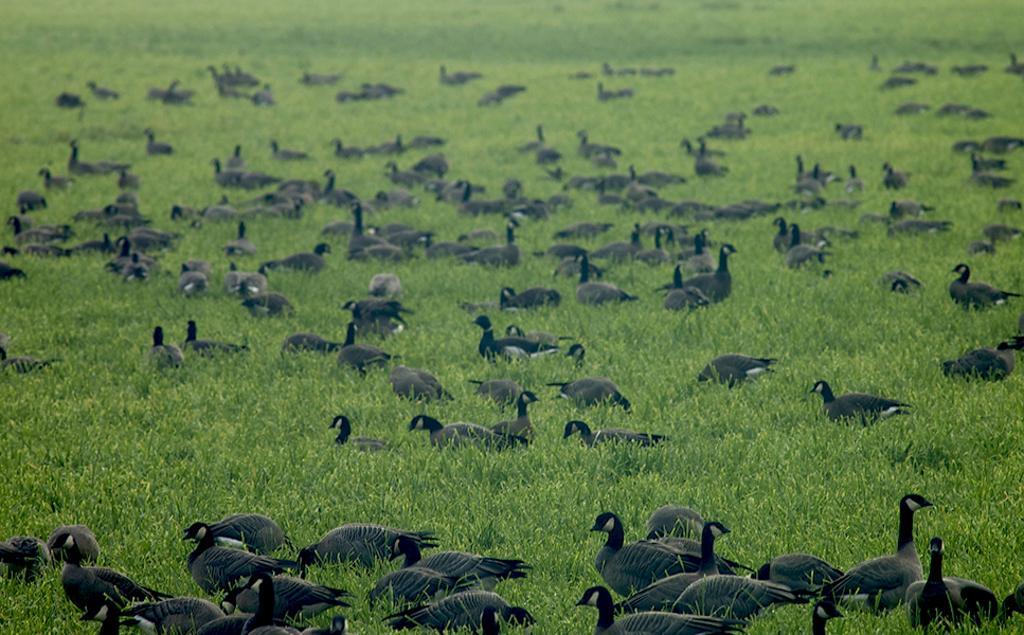Can you describe this image briefly? Here we can see group of birds and grass. 